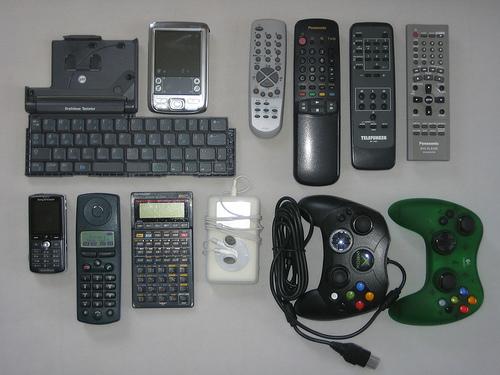How many video game controllers are in the picture?
Be succinct. 2. How many remotes are there?
Keep it brief. 4. How many are silver?
Answer briefly. 3. Which two remotes are the same brand?
Keep it brief. Xbox. Which remote is the biggest?
Concise answer only. Middle. What type of device is on the bottom left?
Concise answer only. Phone. Are all this electronics?
Give a very brief answer. Yes. What is the color of the item in the lower right corner?
Be succinct. Green. How many game remotes are pictured?
Quick response, please. 2. What video game system controller is in the photo?
Write a very short answer. Xbox. Do the brands match?
Quick response, please. No. Which remote control is the most modern one?
Short answer required. Xbox. 